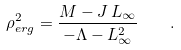Convert formula to latex. <formula><loc_0><loc_0><loc_500><loc_500>\rho _ { e r g } ^ { 2 } = \frac { M - J \, L _ { \infty } } { - \Lambda - L _ { \infty } ^ { 2 } } \quad .</formula> 